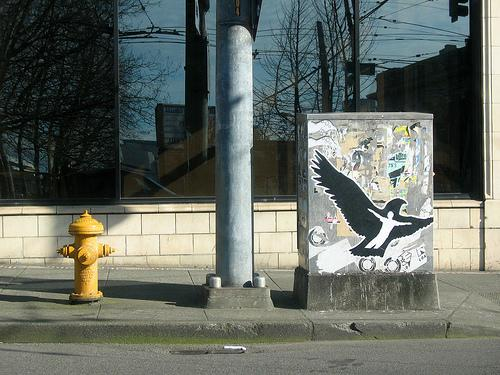Describe the general setting of the image in a few words. A street view with utility structures, graffiti artwork, and sidewalk details such as fire hydrant and traffic pole. Write a one-liner describing the primary focus of the image. A typical urban scene highlighting street utilities, graffiti, and sidewalk features. Describe an object with its surrounding details in the image. The yellow fire hydrant is on the sidewalk, close to a metal traffic pole with its shadow cast on the sidewalk nearby. Briefly describe the conditions of the street and nearby surroundings in the image. The street appears paved and well-maintained, with a sewer drain, traffic pole, fire hydrant, and artwork on a nearby concrete surface. Describe the color and position of the fire hydrant in the image. There is a yellow fire hydrant positioned on the sidewalk near the street and a metal traffic pole. In the image, identify an object with interesting artwork. A drawing of a bird with a person inside on a concrete surface, showing a creative and unconventional artwork. Provide a brief description of the scene in the image. The image portrays a street scene with a yellow fire hydrant, metal traffic pole, sewer drain, and a graffiti artwork of a bird with a human shape inside on a concrete surface. Choose an unusual aspect of the image and describe it briefly. An intriguing element in the image is a bird drawing with a human figure inside, suggesting imaginative street art on a concrete surface. List three objects found in the image. Yellow fire hydrant, metal traffic pole, and a drawing of a bird with a person inside. Mention a distinctive object present in the image. A unique object in the image is the metal box with stickers and artwork, possibly a utilitarian structure turned into a canvas for street art. 